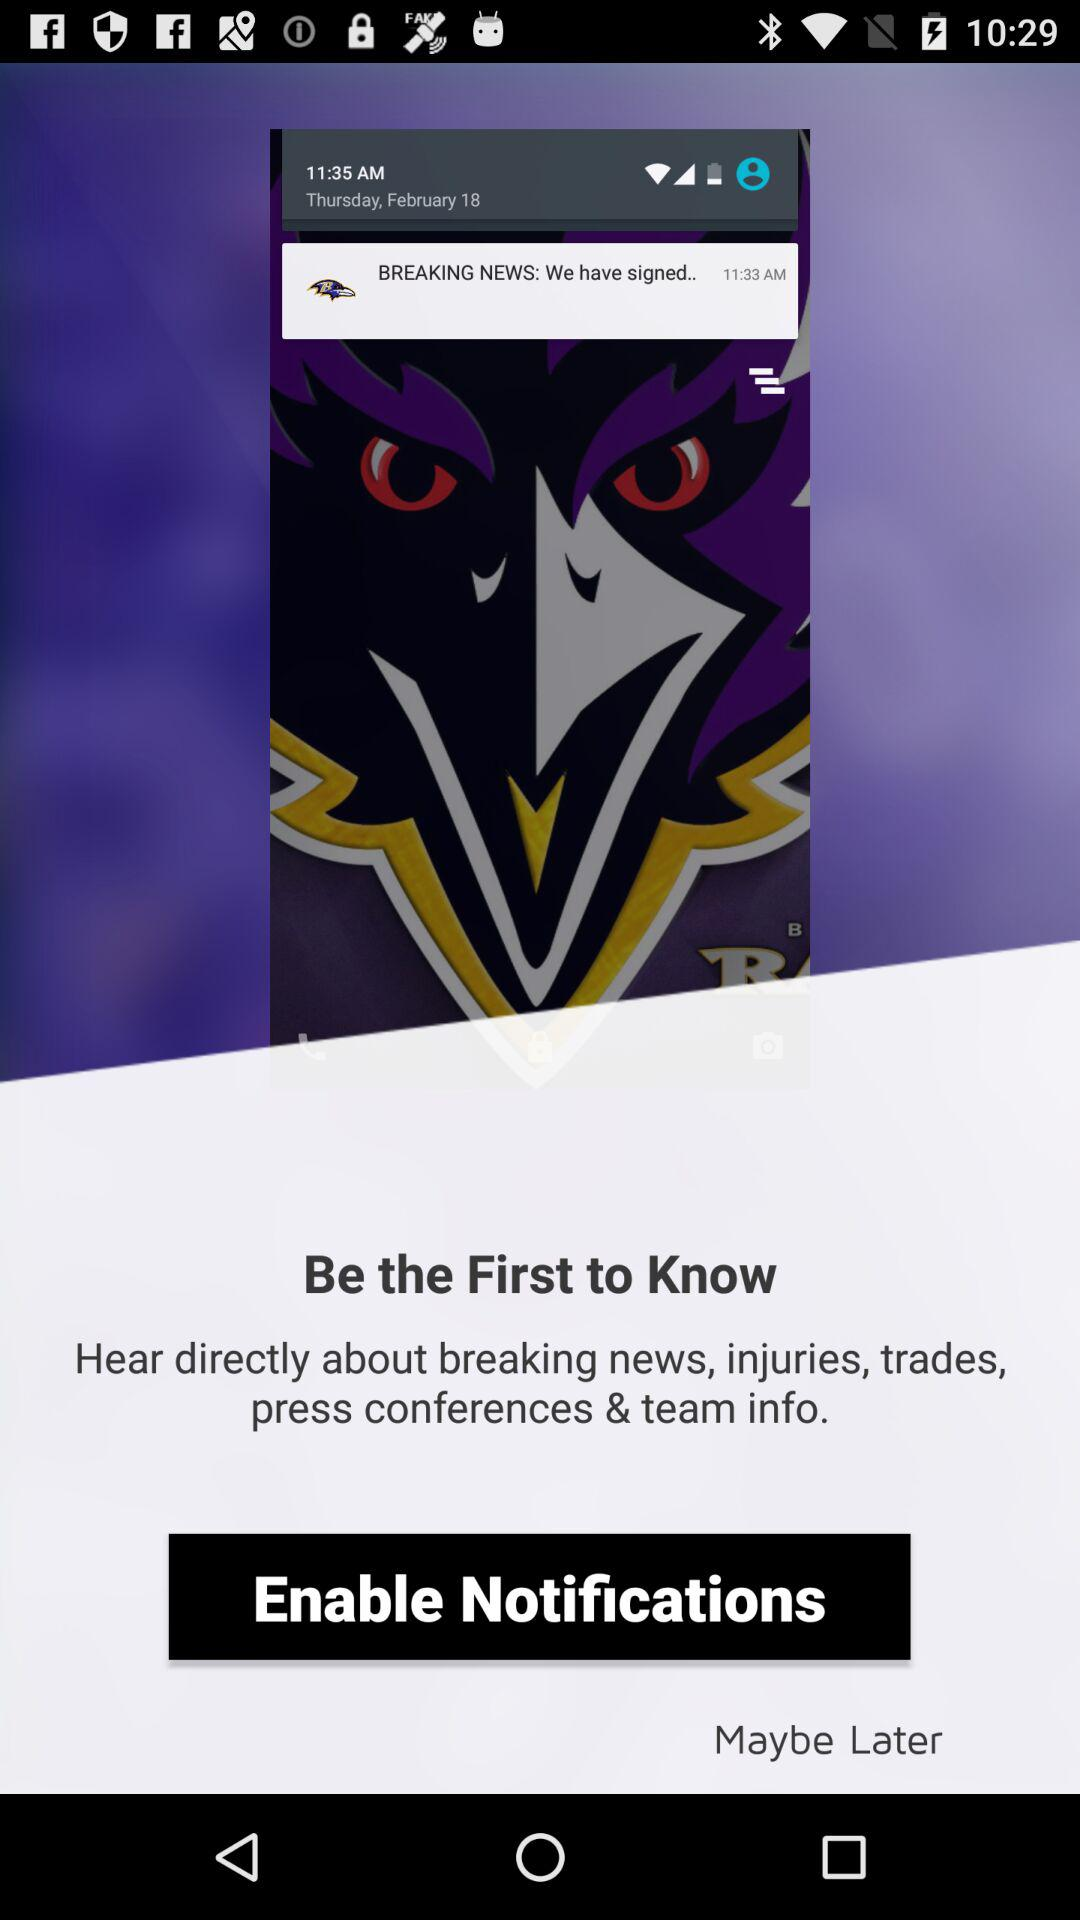What is the mentioned date? The mentioned date is Thursday, February 18. 